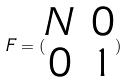<formula> <loc_0><loc_0><loc_500><loc_500>F = ( \begin{matrix} N & 0 \\ 0 & 1 \end{matrix} )</formula> 